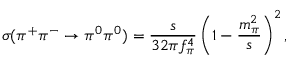<formula> <loc_0><loc_0><loc_500><loc_500>\sigma ( \pi ^ { + } \pi ^ { - } \rightarrow \pi ^ { 0 } \pi ^ { 0 } ) = \frac { s } { 3 2 \pi f _ { \pi } ^ { 4 } } \left ( 1 - \frac { m _ { \pi } ^ { 2 } } { s } \right ) ^ { 2 } ,</formula> 